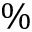Convert formula to latex. <formula><loc_0><loc_0><loc_500><loc_500>\%</formula> 